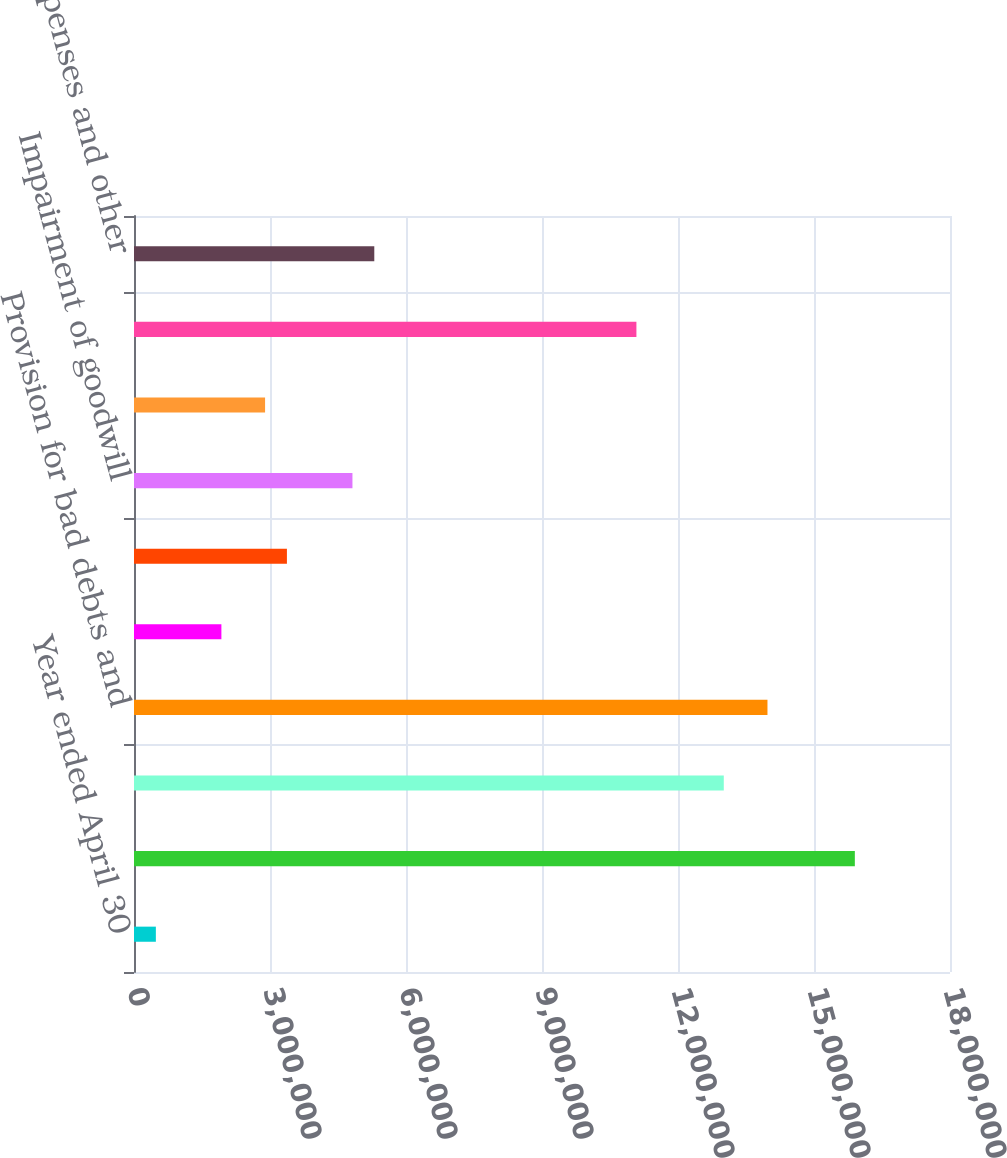Convert chart to OTSL. <chart><loc_0><loc_0><loc_500><loc_500><bar_chart><fcel>Year ended April 30<fcel>Net income<fcel>Depreciation and amortization<fcel>Provision for bad debts and<fcel>Provision for deferred taxes<fcel>Stock-based compensation<fcel>Impairment of goodwill<fcel>Cash and cash equivalents -<fcel>Receivables<fcel>Prepaid expenses and other<nl><fcel>482258<fcel>1.5901e+07<fcel>1.30099e+07<fcel>1.39736e+07<fcel>1.92776e+06<fcel>3.37326e+06<fcel>4.81877e+06<fcel>2.89143e+06<fcel>1.10826e+07<fcel>5.3006e+06<nl></chart> 